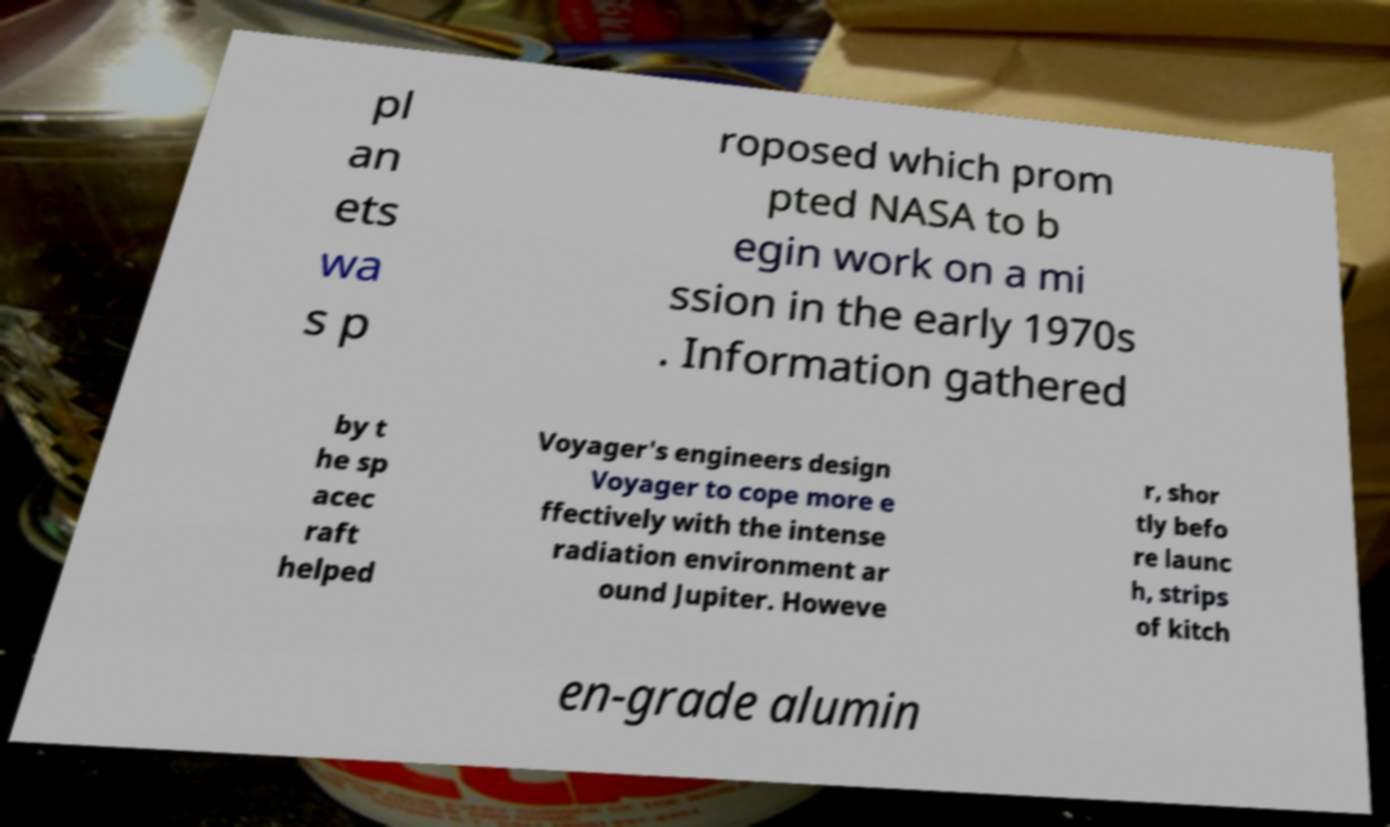What messages or text are displayed in this image? I need them in a readable, typed format. pl an ets wa s p roposed which prom pted NASA to b egin work on a mi ssion in the early 1970s . Information gathered by t he sp acec raft helped Voyager's engineers design Voyager to cope more e ffectively with the intense radiation environment ar ound Jupiter. Howeve r, shor tly befo re launc h, strips of kitch en-grade alumin 